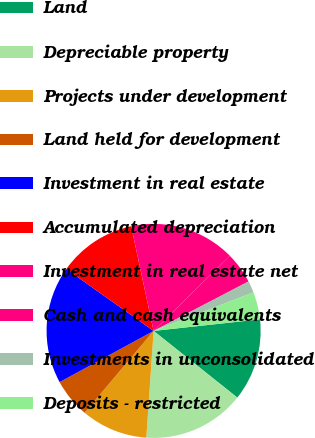Convert chart. <chart><loc_0><loc_0><loc_500><loc_500><pie_chart><fcel>Land<fcel>Depreciable property<fcel>Projects under development<fcel>Land held for development<fcel>Investment in real estate<fcel>Accumulated depreciation<fcel>Investment in real estate net<fcel>Cash and cash equivalents<fcel>Investments in unconsolidated<fcel>Deposits - restricted<nl><fcel>12.43%<fcel>15.38%<fcel>10.06%<fcel>5.92%<fcel>17.75%<fcel>11.83%<fcel>15.97%<fcel>4.74%<fcel>1.78%<fcel>4.14%<nl></chart> 